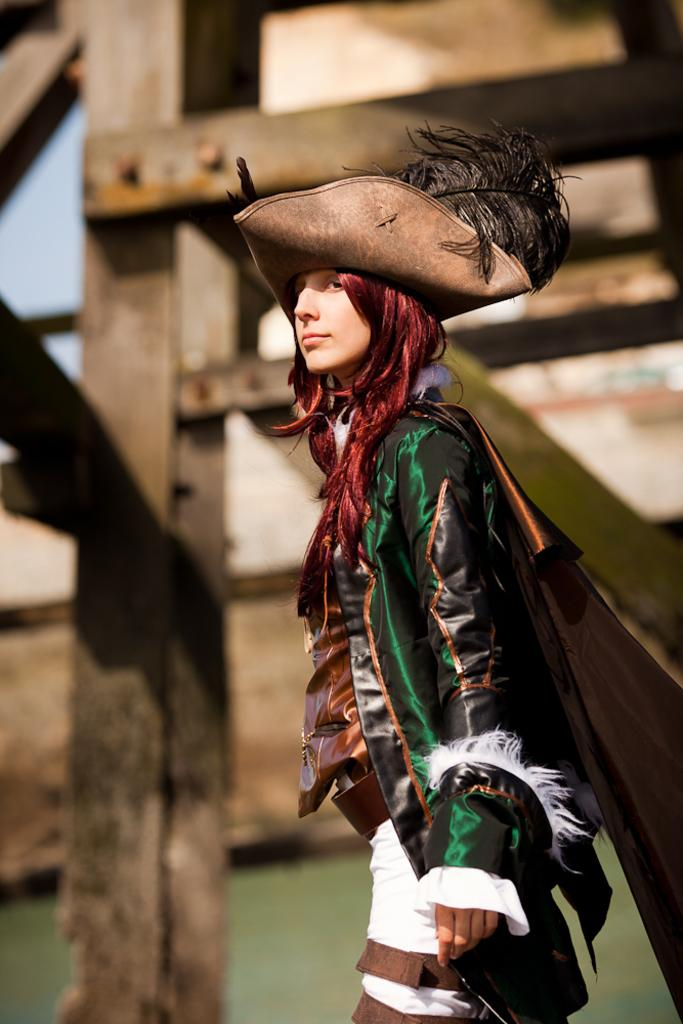Who is the main subject in the image? There is a woman in the image. What is the woman wearing? The woman is wearing a costume. Can you describe the background of the image? The background of the image is blurred. What architectural features can be seen in the image? There are pillars and rods visible in the image. How many pizzas are being served by the lawyer in the image? There is no lawyer or pizzas present in the image. What type of slip is the woman wearing in the image? The woman is not wearing a slip in the image; she is wearing a costume. 